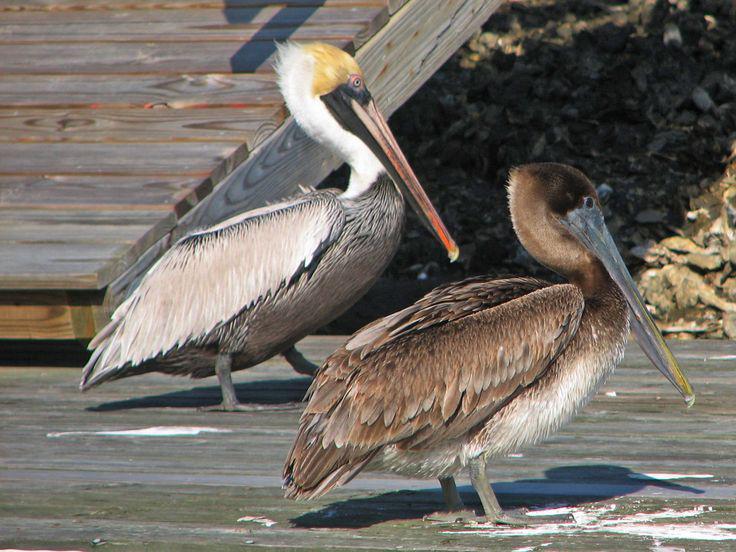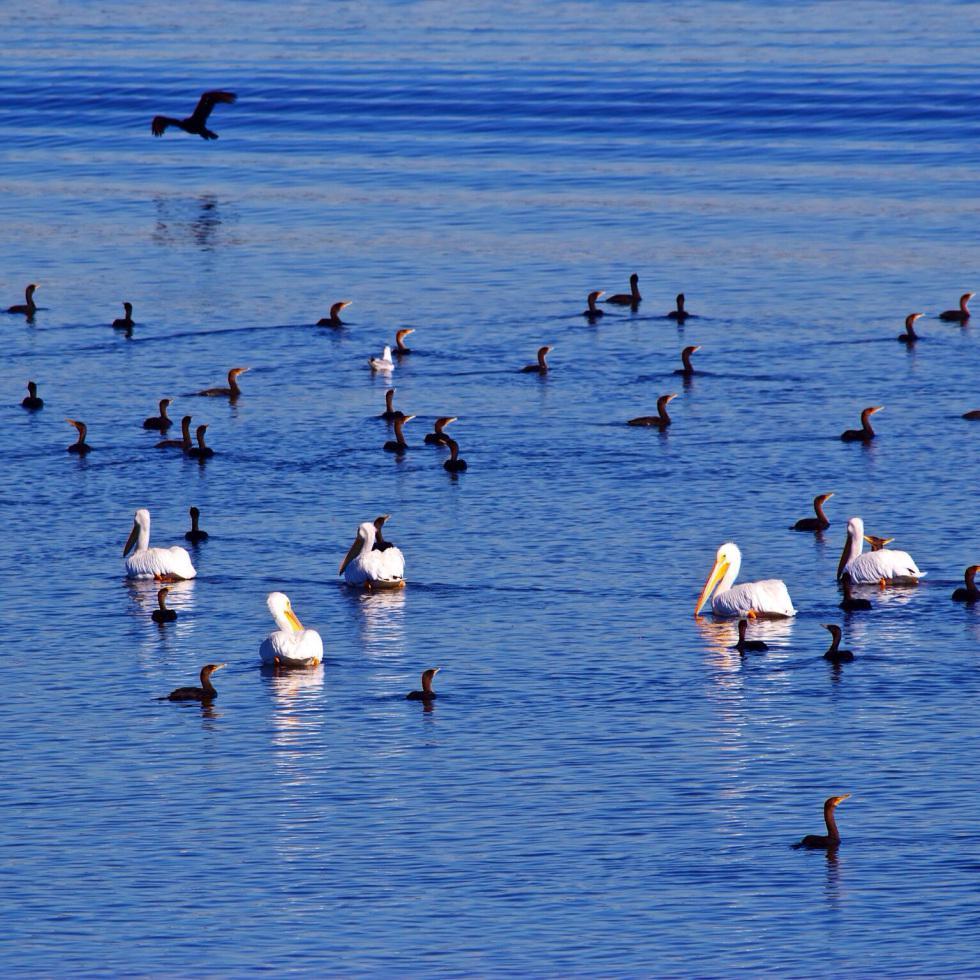The first image is the image on the left, the second image is the image on the right. Analyze the images presented: Is the assertion "Three pelicans perch on wood posts in the water in the left image." valid? Answer yes or no. No. The first image is the image on the left, the second image is the image on the right. Assess this claim about the two images: "Three birds are standing on posts in water in the image on the left.". Correct or not? Answer yes or no. No. 